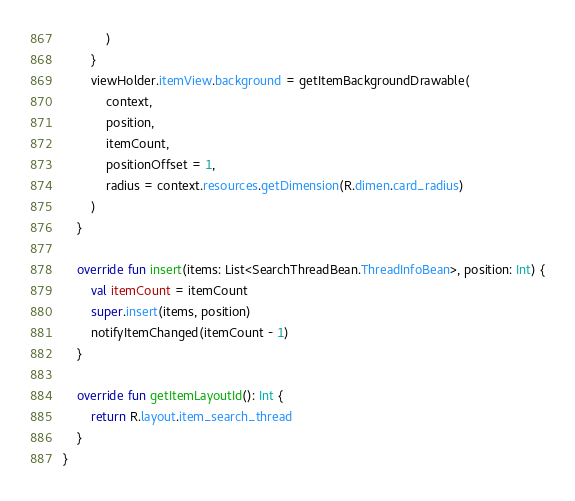Convert code to text. <code><loc_0><loc_0><loc_500><loc_500><_Kotlin_>            )
        }
        viewHolder.itemView.background = getItemBackgroundDrawable(
            context,
            position,
            itemCount,
            positionOffset = 1,
            radius = context.resources.getDimension(R.dimen.card_radius)
        )
    }

    override fun insert(items: List<SearchThreadBean.ThreadInfoBean>, position: Int) {
        val itemCount = itemCount
        super.insert(items, position)
        notifyItemChanged(itemCount - 1)
    }

    override fun getItemLayoutId(): Int {
        return R.layout.item_search_thread
    }
}</code> 